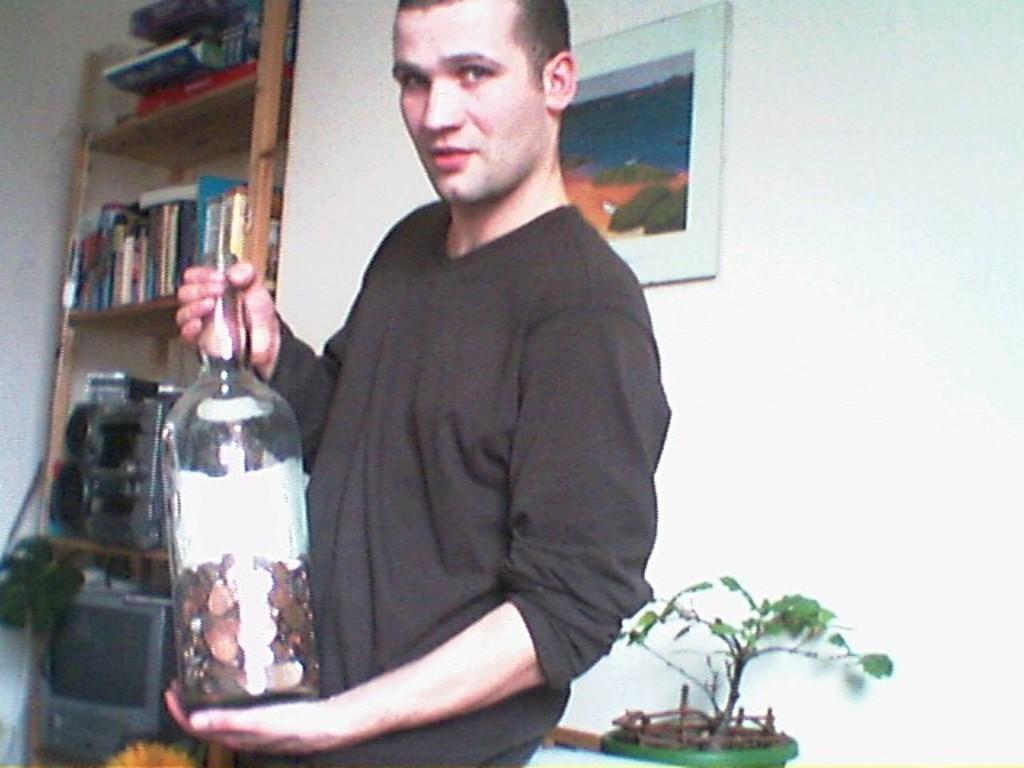Please provide a concise description of this image. In this image I can see a man wearing t-shirt and holding a bottle in his hands. In the background there is a wall, one frame is attached to this wall. Just at the back of this person there is a flower plant. On the left side of the image there is a rack, some books are arranged in that. On the left bottom of the side there is a television and speakers. 